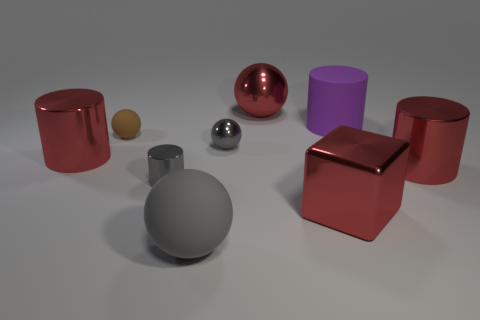How does the lighting affect the appearance of the materials in the scene? The lighting in the scene is diffused and soft, creating gentle shadows and highlights that enhance the visual textures of the materials. Reflective surfaces on some of the objects catch highlights and display specular reflections, emphasizing their glossy textures. Meanwhile, the matte surfaces, like that of the large purple object, absorb more light and do not reflect sharp highlights, thereby reinforcing the perception of a non-glossy, perhaps rougher texture. 